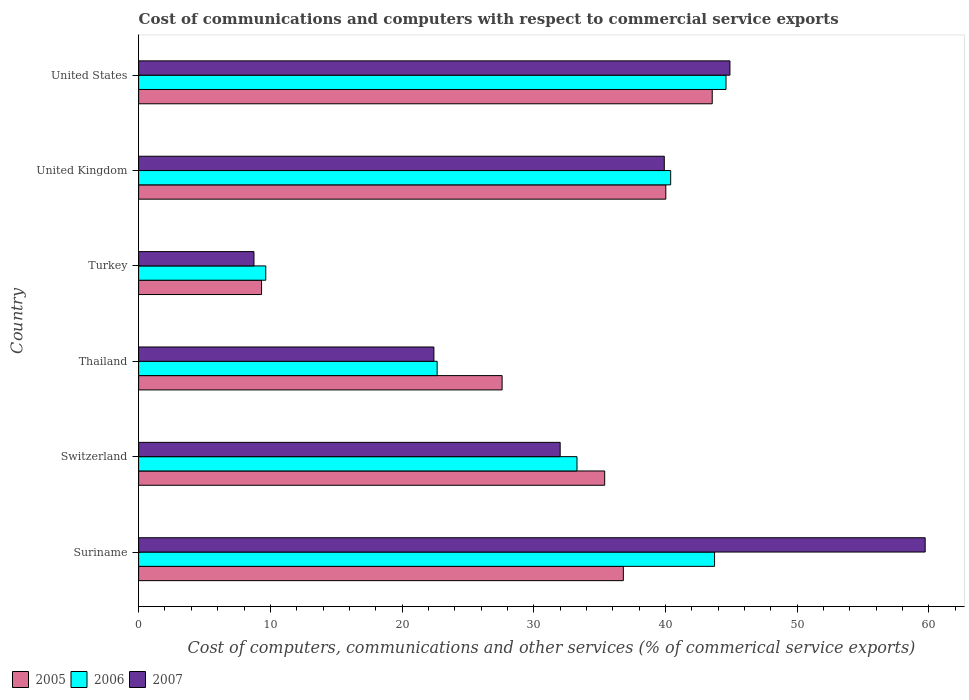How many different coloured bars are there?
Offer a terse response. 3. Are the number of bars on each tick of the Y-axis equal?
Provide a short and direct response. Yes. How many bars are there on the 2nd tick from the bottom?
Offer a very short reply. 3. What is the label of the 4th group of bars from the top?
Give a very brief answer. Thailand. In how many cases, is the number of bars for a given country not equal to the number of legend labels?
Provide a short and direct response. 0. What is the cost of communications and computers in 2005 in United States?
Your answer should be compact. 43.55. Across all countries, what is the maximum cost of communications and computers in 2006?
Provide a short and direct response. 44.6. Across all countries, what is the minimum cost of communications and computers in 2007?
Make the answer very short. 8.76. In which country was the cost of communications and computers in 2007 maximum?
Your response must be concise. Suriname. In which country was the cost of communications and computers in 2005 minimum?
Give a very brief answer. Turkey. What is the total cost of communications and computers in 2005 in the graph?
Ensure brevity in your answer.  192.69. What is the difference between the cost of communications and computers in 2007 in Suriname and that in United States?
Provide a succinct answer. 14.82. What is the difference between the cost of communications and computers in 2005 in Thailand and the cost of communications and computers in 2006 in United Kingdom?
Your answer should be compact. -12.8. What is the average cost of communications and computers in 2006 per country?
Give a very brief answer. 32.39. What is the difference between the cost of communications and computers in 2006 and cost of communications and computers in 2005 in United Kingdom?
Your response must be concise. 0.37. In how many countries, is the cost of communications and computers in 2005 greater than 20 %?
Offer a very short reply. 5. What is the ratio of the cost of communications and computers in 2005 in Suriname to that in United States?
Your answer should be compact. 0.85. What is the difference between the highest and the second highest cost of communications and computers in 2006?
Provide a short and direct response. 0.87. What is the difference between the highest and the lowest cost of communications and computers in 2007?
Provide a short and direct response. 50.96. In how many countries, is the cost of communications and computers in 2005 greater than the average cost of communications and computers in 2005 taken over all countries?
Make the answer very short. 4. Is the sum of the cost of communications and computers in 2007 in Thailand and United Kingdom greater than the maximum cost of communications and computers in 2006 across all countries?
Ensure brevity in your answer.  Yes. What does the 1st bar from the top in United Kingdom represents?
Keep it short and to the point. 2007. What does the 3rd bar from the bottom in United States represents?
Your answer should be compact. 2007. Is it the case that in every country, the sum of the cost of communications and computers in 2005 and cost of communications and computers in 2007 is greater than the cost of communications and computers in 2006?
Offer a very short reply. Yes. Are all the bars in the graph horizontal?
Ensure brevity in your answer.  Yes. How many countries are there in the graph?
Give a very brief answer. 6. Are the values on the major ticks of X-axis written in scientific E-notation?
Ensure brevity in your answer.  No. Where does the legend appear in the graph?
Offer a terse response. Bottom left. How many legend labels are there?
Offer a terse response. 3. What is the title of the graph?
Provide a short and direct response. Cost of communications and computers with respect to commercial service exports. Does "1997" appear as one of the legend labels in the graph?
Your response must be concise. No. What is the label or title of the X-axis?
Ensure brevity in your answer.  Cost of computers, communications and other services (% of commerical service exports). What is the label or title of the Y-axis?
Offer a terse response. Country. What is the Cost of computers, communications and other services (% of commerical service exports) in 2005 in Suriname?
Make the answer very short. 36.8. What is the Cost of computers, communications and other services (% of commerical service exports) of 2006 in Suriname?
Your answer should be compact. 43.73. What is the Cost of computers, communications and other services (% of commerical service exports) of 2007 in Suriname?
Provide a succinct answer. 59.72. What is the Cost of computers, communications and other services (% of commerical service exports) in 2005 in Switzerland?
Ensure brevity in your answer.  35.39. What is the Cost of computers, communications and other services (% of commerical service exports) in 2006 in Switzerland?
Your answer should be very brief. 33.28. What is the Cost of computers, communications and other services (% of commerical service exports) in 2007 in Switzerland?
Your answer should be very brief. 32. What is the Cost of computers, communications and other services (% of commerical service exports) in 2005 in Thailand?
Offer a very short reply. 27.6. What is the Cost of computers, communications and other services (% of commerical service exports) in 2006 in Thailand?
Provide a succinct answer. 22.66. What is the Cost of computers, communications and other services (% of commerical service exports) in 2007 in Thailand?
Your response must be concise. 22.42. What is the Cost of computers, communications and other services (% of commerical service exports) in 2005 in Turkey?
Your answer should be compact. 9.33. What is the Cost of computers, communications and other services (% of commerical service exports) in 2006 in Turkey?
Give a very brief answer. 9.65. What is the Cost of computers, communications and other services (% of commerical service exports) in 2007 in Turkey?
Offer a very short reply. 8.76. What is the Cost of computers, communications and other services (% of commerical service exports) in 2005 in United Kingdom?
Your answer should be compact. 40.03. What is the Cost of computers, communications and other services (% of commerical service exports) of 2006 in United Kingdom?
Keep it short and to the point. 40.39. What is the Cost of computers, communications and other services (% of commerical service exports) in 2007 in United Kingdom?
Provide a succinct answer. 39.91. What is the Cost of computers, communications and other services (% of commerical service exports) in 2005 in United States?
Your answer should be very brief. 43.55. What is the Cost of computers, communications and other services (% of commerical service exports) in 2006 in United States?
Your response must be concise. 44.6. What is the Cost of computers, communications and other services (% of commerical service exports) in 2007 in United States?
Ensure brevity in your answer.  44.89. Across all countries, what is the maximum Cost of computers, communications and other services (% of commerical service exports) in 2005?
Give a very brief answer. 43.55. Across all countries, what is the maximum Cost of computers, communications and other services (% of commerical service exports) in 2006?
Offer a terse response. 44.6. Across all countries, what is the maximum Cost of computers, communications and other services (% of commerical service exports) in 2007?
Provide a succinct answer. 59.72. Across all countries, what is the minimum Cost of computers, communications and other services (% of commerical service exports) of 2005?
Your answer should be compact. 9.33. Across all countries, what is the minimum Cost of computers, communications and other services (% of commerical service exports) in 2006?
Your answer should be very brief. 9.65. Across all countries, what is the minimum Cost of computers, communications and other services (% of commerical service exports) in 2007?
Give a very brief answer. 8.76. What is the total Cost of computers, communications and other services (% of commerical service exports) of 2005 in the graph?
Offer a very short reply. 192.69. What is the total Cost of computers, communications and other services (% of commerical service exports) of 2006 in the graph?
Give a very brief answer. 194.32. What is the total Cost of computers, communications and other services (% of commerical service exports) in 2007 in the graph?
Your response must be concise. 207.7. What is the difference between the Cost of computers, communications and other services (% of commerical service exports) in 2005 in Suriname and that in Switzerland?
Offer a very short reply. 1.42. What is the difference between the Cost of computers, communications and other services (% of commerical service exports) in 2006 in Suriname and that in Switzerland?
Provide a short and direct response. 10.44. What is the difference between the Cost of computers, communications and other services (% of commerical service exports) in 2007 in Suriname and that in Switzerland?
Ensure brevity in your answer.  27.71. What is the difference between the Cost of computers, communications and other services (% of commerical service exports) in 2005 in Suriname and that in Thailand?
Offer a terse response. 9.21. What is the difference between the Cost of computers, communications and other services (% of commerical service exports) of 2006 in Suriname and that in Thailand?
Ensure brevity in your answer.  21.06. What is the difference between the Cost of computers, communications and other services (% of commerical service exports) in 2007 in Suriname and that in Thailand?
Make the answer very short. 37.3. What is the difference between the Cost of computers, communications and other services (% of commerical service exports) in 2005 in Suriname and that in Turkey?
Your answer should be compact. 27.47. What is the difference between the Cost of computers, communications and other services (% of commerical service exports) of 2006 in Suriname and that in Turkey?
Offer a terse response. 34.07. What is the difference between the Cost of computers, communications and other services (% of commerical service exports) of 2007 in Suriname and that in Turkey?
Ensure brevity in your answer.  50.96. What is the difference between the Cost of computers, communications and other services (% of commerical service exports) in 2005 in Suriname and that in United Kingdom?
Offer a very short reply. -3.22. What is the difference between the Cost of computers, communications and other services (% of commerical service exports) in 2006 in Suriname and that in United Kingdom?
Ensure brevity in your answer.  3.33. What is the difference between the Cost of computers, communications and other services (% of commerical service exports) of 2007 in Suriname and that in United Kingdom?
Provide a short and direct response. 19.81. What is the difference between the Cost of computers, communications and other services (% of commerical service exports) of 2005 in Suriname and that in United States?
Give a very brief answer. -6.75. What is the difference between the Cost of computers, communications and other services (% of commerical service exports) in 2006 in Suriname and that in United States?
Your answer should be very brief. -0.87. What is the difference between the Cost of computers, communications and other services (% of commerical service exports) in 2007 in Suriname and that in United States?
Ensure brevity in your answer.  14.82. What is the difference between the Cost of computers, communications and other services (% of commerical service exports) in 2005 in Switzerland and that in Thailand?
Provide a succinct answer. 7.79. What is the difference between the Cost of computers, communications and other services (% of commerical service exports) of 2006 in Switzerland and that in Thailand?
Offer a very short reply. 10.62. What is the difference between the Cost of computers, communications and other services (% of commerical service exports) in 2007 in Switzerland and that in Thailand?
Your answer should be compact. 9.59. What is the difference between the Cost of computers, communications and other services (% of commerical service exports) in 2005 in Switzerland and that in Turkey?
Offer a terse response. 26.05. What is the difference between the Cost of computers, communications and other services (% of commerical service exports) of 2006 in Switzerland and that in Turkey?
Your response must be concise. 23.63. What is the difference between the Cost of computers, communications and other services (% of commerical service exports) of 2007 in Switzerland and that in Turkey?
Give a very brief answer. 23.25. What is the difference between the Cost of computers, communications and other services (% of commerical service exports) of 2005 in Switzerland and that in United Kingdom?
Offer a very short reply. -4.64. What is the difference between the Cost of computers, communications and other services (% of commerical service exports) in 2006 in Switzerland and that in United Kingdom?
Give a very brief answer. -7.11. What is the difference between the Cost of computers, communications and other services (% of commerical service exports) in 2007 in Switzerland and that in United Kingdom?
Offer a terse response. -7.91. What is the difference between the Cost of computers, communications and other services (% of commerical service exports) of 2005 in Switzerland and that in United States?
Make the answer very short. -8.17. What is the difference between the Cost of computers, communications and other services (% of commerical service exports) of 2006 in Switzerland and that in United States?
Provide a succinct answer. -11.31. What is the difference between the Cost of computers, communications and other services (% of commerical service exports) of 2007 in Switzerland and that in United States?
Ensure brevity in your answer.  -12.89. What is the difference between the Cost of computers, communications and other services (% of commerical service exports) of 2005 in Thailand and that in Turkey?
Your response must be concise. 18.26. What is the difference between the Cost of computers, communications and other services (% of commerical service exports) in 2006 in Thailand and that in Turkey?
Ensure brevity in your answer.  13.01. What is the difference between the Cost of computers, communications and other services (% of commerical service exports) of 2007 in Thailand and that in Turkey?
Make the answer very short. 13.66. What is the difference between the Cost of computers, communications and other services (% of commerical service exports) in 2005 in Thailand and that in United Kingdom?
Your answer should be very brief. -12.43. What is the difference between the Cost of computers, communications and other services (% of commerical service exports) in 2006 in Thailand and that in United Kingdom?
Offer a very short reply. -17.73. What is the difference between the Cost of computers, communications and other services (% of commerical service exports) in 2007 in Thailand and that in United Kingdom?
Your response must be concise. -17.49. What is the difference between the Cost of computers, communications and other services (% of commerical service exports) in 2005 in Thailand and that in United States?
Your response must be concise. -15.95. What is the difference between the Cost of computers, communications and other services (% of commerical service exports) of 2006 in Thailand and that in United States?
Provide a succinct answer. -21.93. What is the difference between the Cost of computers, communications and other services (% of commerical service exports) of 2007 in Thailand and that in United States?
Your response must be concise. -22.48. What is the difference between the Cost of computers, communications and other services (% of commerical service exports) in 2005 in Turkey and that in United Kingdom?
Provide a succinct answer. -30.69. What is the difference between the Cost of computers, communications and other services (% of commerical service exports) of 2006 in Turkey and that in United Kingdom?
Provide a succinct answer. -30.74. What is the difference between the Cost of computers, communications and other services (% of commerical service exports) in 2007 in Turkey and that in United Kingdom?
Offer a terse response. -31.15. What is the difference between the Cost of computers, communications and other services (% of commerical service exports) in 2005 in Turkey and that in United States?
Your response must be concise. -34.22. What is the difference between the Cost of computers, communications and other services (% of commerical service exports) in 2006 in Turkey and that in United States?
Offer a very short reply. -34.94. What is the difference between the Cost of computers, communications and other services (% of commerical service exports) in 2007 in Turkey and that in United States?
Give a very brief answer. -36.14. What is the difference between the Cost of computers, communications and other services (% of commerical service exports) in 2005 in United Kingdom and that in United States?
Your answer should be very brief. -3.53. What is the difference between the Cost of computers, communications and other services (% of commerical service exports) in 2006 in United Kingdom and that in United States?
Give a very brief answer. -4.2. What is the difference between the Cost of computers, communications and other services (% of commerical service exports) in 2007 in United Kingdom and that in United States?
Your answer should be very brief. -4.98. What is the difference between the Cost of computers, communications and other services (% of commerical service exports) of 2005 in Suriname and the Cost of computers, communications and other services (% of commerical service exports) of 2006 in Switzerland?
Your answer should be compact. 3.52. What is the difference between the Cost of computers, communications and other services (% of commerical service exports) of 2005 in Suriname and the Cost of computers, communications and other services (% of commerical service exports) of 2007 in Switzerland?
Provide a short and direct response. 4.8. What is the difference between the Cost of computers, communications and other services (% of commerical service exports) of 2006 in Suriname and the Cost of computers, communications and other services (% of commerical service exports) of 2007 in Switzerland?
Keep it short and to the point. 11.72. What is the difference between the Cost of computers, communications and other services (% of commerical service exports) of 2005 in Suriname and the Cost of computers, communications and other services (% of commerical service exports) of 2006 in Thailand?
Ensure brevity in your answer.  14.14. What is the difference between the Cost of computers, communications and other services (% of commerical service exports) of 2005 in Suriname and the Cost of computers, communications and other services (% of commerical service exports) of 2007 in Thailand?
Your answer should be compact. 14.38. What is the difference between the Cost of computers, communications and other services (% of commerical service exports) in 2006 in Suriname and the Cost of computers, communications and other services (% of commerical service exports) in 2007 in Thailand?
Keep it short and to the point. 21.31. What is the difference between the Cost of computers, communications and other services (% of commerical service exports) of 2005 in Suriname and the Cost of computers, communications and other services (% of commerical service exports) of 2006 in Turkey?
Offer a terse response. 27.15. What is the difference between the Cost of computers, communications and other services (% of commerical service exports) in 2005 in Suriname and the Cost of computers, communications and other services (% of commerical service exports) in 2007 in Turkey?
Provide a short and direct response. 28.05. What is the difference between the Cost of computers, communications and other services (% of commerical service exports) of 2006 in Suriname and the Cost of computers, communications and other services (% of commerical service exports) of 2007 in Turkey?
Your response must be concise. 34.97. What is the difference between the Cost of computers, communications and other services (% of commerical service exports) in 2005 in Suriname and the Cost of computers, communications and other services (% of commerical service exports) in 2006 in United Kingdom?
Your response must be concise. -3.59. What is the difference between the Cost of computers, communications and other services (% of commerical service exports) of 2005 in Suriname and the Cost of computers, communications and other services (% of commerical service exports) of 2007 in United Kingdom?
Make the answer very short. -3.11. What is the difference between the Cost of computers, communications and other services (% of commerical service exports) in 2006 in Suriname and the Cost of computers, communications and other services (% of commerical service exports) in 2007 in United Kingdom?
Ensure brevity in your answer.  3.82. What is the difference between the Cost of computers, communications and other services (% of commerical service exports) in 2005 in Suriname and the Cost of computers, communications and other services (% of commerical service exports) in 2006 in United States?
Give a very brief answer. -7.79. What is the difference between the Cost of computers, communications and other services (% of commerical service exports) in 2005 in Suriname and the Cost of computers, communications and other services (% of commerical service exports) in 2007 in United States?
Make the answer very short. -8.09. What is the difference between the Cost of computers, communications and other services (% of commerical service exports) in 2006 in Suriname and the Cost of computers, communications and other services (% of commerical service exports) in 2007 in United States?
Provide a succinct answer. -1.17. What is the difference between the Cost of computers, communications and other services (% of commerical service exports) of 2005 in Switzerland and the Cost of computers, communications and other services (% of commerical service exports) of 2006 in Thailand?
Offer a very short reply. 12.72. What is the difference between the Cost of computers, communications and other services (% of commerical service exports) in 2005 in Switzerland and the Cost of computers, communications and other services (% of commerical service exports) in 2007 in Thailand?
Ensure brevity in your answer.  12.97. What is the difference between the Cost of computers, communications and other services (% of commerical service exports) of 2006 in Switzerland and the Cost of computers, communications and other services (% of commerical service exports) of 2007 in Thailand?
Your answer should be very brief. 10.86. What is the difference between the Cost of computers, communications and other services (% of commerical service exports) in 2005 in Switzerland and the Cost of computers, communications and other services (% of commerical service exports) in 2006 in Turkey?
Keep it short and to the point. 25.73. What is the difference between the Cost of computers, communications and other services (% of commerical service exports) of 2005 in Switzerland and the Cost of computers, communications and other services (% of commerical service exports) of 2007 in Turkey?
Your response must be concise. 26.63. What is the difference between the Cost of computers, communications and other services (% of commerical service exports) of 2006 in Switzerland and the Cost of computers, communications and other services (% of commerical service exports) of 2007 in Turkey?
Ensure brevity in your answer.  24.53. What is the difference between the Cost of computers, communications and other services (% of commerical service exports) in 2005 in Switzerland and the Cost of computers, communications and other services (% of commerical service exports) in 2006 in United Kingdom?
Make the answer very short. -5.01. What is the difference between the Cost of computers, communications and other services (% of commerical service exports) in 2005 in Switzerland and the Cost of computers, communications and other services (% of commerical service exports) in 2007 in United Kingdom?
Your response must be concise. -4.52. What is the difference between the Cost of computers, communications and other services (% of commerical service exports) in 2006 in Switzerland and the Cost of computers, communications and other services (% of commerical service exports) in 2007 in United Kingdom?
Provide a short and direct response. -6.63. What is the difference between the Cost of computers, communications and other services (% of commerical service exports) in 2005 in Switzerland and the Cost of computers, communications and other services (% of commerical service exports) in 2006 in United States?
Your answer should be compact. -9.21. What is the difference between the Cost of computers, communications and other services (% of commerical service exports) of 2005 in Switzerland and the Cost of computers, communications and other services (% of commerical service exports) of 2007 in United States?
Make the answer very short. -9.51. What is the difference between the Cost of computers, communications and other services (% of commerical service exports) of 2006 in Switzerland and the Cost of computers, communications and other services (% of commerical service exports) of 2007 in United States?
Ensure brevity in your answer.  -11.61. What is the difference between the Cost of computers, communications and other services (% of commerical service exports) in 2005 in Thailand and the Cost of computers, communications and other services (% of commerical service exports) in 2006 in Turkey?
Provide a short and direct response. 17.94. What is the difference between the Cost of computers, communications and other services (% of commerical service exports) of 2005 in Thailand and the Cost of computers, communications and other services (% of commerical service exports) of 2007 in Turkey?
Give a very brief answer. 18.84. What is the difference between the Cost of computers, communications and other services (% of commerical service exports) of 2006 in Thailand and the Cost of computers, communications and other services (% of commerical service exports) of 2007 in Turkey?
Give a very brief answer. 13.91. What is the difference between the Cost of computers, communications and other services (% of commerical service exports) in 2005 in Thailand and the Cost of computers, communications and other services (% of commerical service exports) in 2006 in United Kingdom?
Provide a short and direct response. -12.8. What is the difference between the Cost of computers, communications and other services (% of commerical service exports) of 2005 in Thailand and the Cost of computers, communications and other services (% of commerical service exports) of 2007 in United Kingdom?
Give a very brief answer. -12.31. What is the difference between the Cost of computers, communications and other services (% of commerical service exports) of 2006 in Thailand and the Cost of computers, communications and other services (% of commerical service exports) of 2007 in United Kingdom?
Your response must be concise. -17.25. What is the difference between the Cost of computers, communications and other services (% of commerical service exports) in 2005 in Thailand and the Cost of computers, communications and other services (% of commerical service exports) in 2006 in United States?
Make the answer very short. -17. What is the difference between the Cost of computers, communications and other services (% of commerical service exports) in 2005 in Thailand and the Cost of computers, communications and other services (% of commerical service exports) in 2007 in United States?
Your answer should be very brief. -17.3. What is the difference between the Cost of computers, communications and other services (% of commerical service exports) of 2006 in Thailand and the Cost of computers, communications and other services (% of commerical service exports) of 2007 in United States?
Give a very brief answer. -22.23. What is the difference between the Cost of computers, communications and other services (% of commerical service exports) of 2005 in Turkey and the Cost of computers, communications and other services (% of commerical service exports) of 2006 in United Kingdom?
Give a very brief answer. -31.06. What is the difference between the Cost of computers, communications and other services (% of commerical service exports) in 2005 in Turkey and the Cost of computers, communications and other services (% of commerical service exports) in 2007 in United Kingdom?
Offer a very short reply. -30.58. What is the difference between the Cost of computers, communications and other services (% of commerical service exports) of 2006 in Turkey and the Cost of computers, communications and other services (% of commerical service exports) of 2007 in United Kingdom?
Keep it short and to the point. -30.26. What is the difference between the Cost of computers, communications and other services (% of commerical service exports) of 2005 in Turkey and the Cost of computers, communications and other services (% of commerical service exports) of 2006 in United States?
Offer a terse response. -35.26. What is the difference between the Cost of computers, communications and other services (% of commerical service exports) of 2005 in Turkey and the Cost of computers, communications and other services (% of commerical service exports) of 2007 in United States?
Ensure brevity in your answer.  -35.56. What is the difference between the Cost of computers, communications and other services (% of commerical service exports) in 2006 in Turkey and the Cost of computers, communications and other services (% of commerical service exports) in 2007 in United States?
Your answer should be compact. -35.24. What is the difference between the Cost of computers, communications and other services (% of commerical service exports) of 2005 in United Kingdom and the Cost of computers, communications and other services (% of commerical service exports) of 2006 in United States?
Give a very brief answer. -4.57. What is the difference between the Cost of computers, communications and other services (% of commerical service exports) of 2005 in United Kingdom and the Cost of computers, communications and other services (% of commerical service exports) of 2007 in United States?
Make the answer very short. -4.87. What is the difference between the Cost of computers, communications and other services (% of commerical service exports) of 2006 in United Kingdom and the Cost of computers, communications and other services (% of commerical service exports) of 2007 in United States?
Keep it short and to the point. -4.5. What is the average Cost of computers, communications and other services (% of commerical service exports) in 2005 per country?
Your response must be concise. 32.12. What is the average Cost of computers, communications and other services (% of commerical service exports) of 2006 per country?
Give a very brief answer. 32.39. What is the average Cost of computers, communications and other services (% of commerical service exports) in 2007 per country?
Offer a terse response. 34.62. What is the difference between the Cost of computers, communications and other services (% of commerical service exports) of 2005 and Cost of computers, communications and other services (% of commerical service exports) of 2006 in Suriname?
Provide a succinct answer. -6.92. What is the difference between the Cost of computers, communications and other services (% of commerical service exports) of 2005 and Cost of computers, communications and other services (% of commerical service exports) of 2007 in Suriname?
Provide a succinct answer. -22.91. What is the difference between the Cost of computers, communications and other services (% of commerical service exports) in 2006 and Cost of computers, communications and other services (% of commerical service exports) in 2007 in Suriname?
Offer a terse response. -15.99. What is the difference between the Cost of computers, communications and other services (% of commerical service exports) of 2005 and Cost of computers, communications and other services (% of commerical service exports) of 2006 in Switzerland?
Ensure brevity in your answer.  2.1. What is the difference between the Cost of computers, communications and other services (% of commerical service exports) of 2005 and Cost of computers, communications and other services (% of commerical service exports) of 2007 in Switzerland?
Ensure brevity in your answer.  3.38. What is the difference between the Cost of computers, communications and other services (% of commerical service exports) of 2006 and Cost of computers, communications and other services (% of commerical service exports) of 2007 in Switzerland?
Your response must be concise. 1.28. What is the difference between the Cost of computers, communications and other services (% of commerical service exports) of 2005 and Cost of computers, communications and other services (% of commerical service exports) of 2006 in Thailand?
Ensure brevity in your answer.  4.93. What is the difference between the Cost of computers, communications and other services (% of commerical service exports) of 2005 and Cost of computers, communications and other services (% of commerical service exports) of 2007 in Thailand?
Offer a very short reply. 5.18. What is the difference between the Cost of computers, communications and other services (% of commerical service exports) in 2006 and Cost of computers, communications and other services (% of commerical service exports) in 2007 in Thailand?
Offer a very short reply. 0.25. What is the difference between the Cost of computers, communications and other services (% of commerical service exports) of 2005 and Cost of computers, communications and other services (% of commerical service exports) of 2006 in Turkey?
Provide a short and direct response. -0.32. What is the difference between the Cost of computers, communications and other services (% of commerical service exports) in 2005 and Cost of computers, communications and other services (% of commerical service exports) in 2007 in Turkey?
Offer a very short reply. 0.58. What is the difference between the Cost of computers, communications and other services (% of commerical service exports) of 2006 and Cost of computers, communications and other services (% of commerical service exports) of 2007 in Turkey?
Give a very brief answer. 0.9. What is the difference between the Cost of computers, communications and other services (% of commerical service exports) of 2005 and Cost of computers, communications and other services (% of commerical service exports) of 2006 in United Kingdom?
Offer a terse response. -0.37. What is the difference between the Cost of computers, communications and other services (% of commerical service exports) of 2005 and Cost of computers, communications and other services (% of commerical service exports) of 2007 in United Kingdom?
Your answer should be very brief. 0.12. What is the difference between the Cost of computers, communications and other services (% of commerical service exports) in 2006 and Cost of computers, communications and other services (% of commerical service exports) in 2007 in United Kingdom?
Give a very brief answer. 0.48. What is the difference between the Cost of computers, communications and other services (% of commerical service exports) of 2005 and Cost of computers, communications and other services (% of commerical service exports) of 2006 in United States?
Offer a terse response. -1.05. What is the difference between the Cost of computers, communications and other services (% of commerical service exports) of 2005 and Cost of computers, communications and other services (% of commerical service exports) of 2007 in United States?
Offer a terse response. -1.34. What is the difference between the Cost of computers, communications and other services (% of commerical service exports) of 2006 and Cost of computers, communications and other services (% of commerical service exports) of 2007 in United States?
Make the answer very short. -0.3. What is the ratio of the Cost of computers, communications and other services (% of commerical service exports) of 2006 in Suriname to that in Switzerland?
Your answer should be very brief. 1.31. What is the ratio of the Cost of computers, communications and other services (% of commerical service exports) of 2007 in Suriname to that in Switzerland?
Ensure brevity in your answer.  1.87. What is the ratio of the Cost of computers, communications and other services (% of commerical service exports) of 2005 in Suriname to that in Thailand?
Your response must be concise. 1.33. What is the ratio of the Cost of computers, communications and other services (% of commerical service exports) of 2006 in Suriname to that in Thailand?
Your response must be concise. 1.93. What is the ratio of the Cost of computers, communications and other services (% of commerical service exports) of 2007 in Suriname to that in Thailand?
Provide a succinct answer. 2.66. What is the ratio of the Cost of computers, communications and other services (% of commerical service exports) in 2005 in Suriname to that in Turkey?
Provide a succinct answer. 3.94. What is the ratio of the Cost of computers, communications and other services (% of commerical service exports) in 2006 in Suriname to that in Turkey?
Offer a terse response. 4.53. What is the ratio of the Cost of computers, communications and other services (% of commerical service exports) in 2007 in Suriname to that in Turkey?
Keep it short and to the point. 6.82. What is the ratio of the Cost of computers, communications and other services (% of commerical service exports) in 2005 in Suriname to that in United Kingdom?
Offer a terse response. 0.92. What is the ratio of the Cost of computers, communications and other services (% of commerical service exports) in 2006 in Suriname to that in United Kingdom?
Make the answer very short. 1.08. What is the ratio of the Cost of computers, communications and other services (% of commerical service exports) in 2007 in Suriname to that in United Kingdom?
Your response must be concise. 1.5. What is the ratio of the Cost of computers, communications and other services (% of commerical service exports) in 2005 in Suriname to that in United States?
Offer a terse response. 0.84. What is the ratio of the Cost of computers, communications and other services (% of commerical service exports) of 2006 in Suriname to that in United States?
Your answer should be compact. 0.98. What is the ratio of the Cost of computers, communications and other services (% of commerical service exports) of 2007 in Suriname to that in United States?
Offer a very short reply. 1.33. What is the ratio of the Cost of computers, communications and other services (% of commerical service exports) of 2005 in Switzerland to that in Thailand?
Keep it short and to the point. 1.28. What is the ratio of the Cost of computers, communications and other services (% of commerical service exports) of 2006 in Switzerland to that in Thailand?
Your answer should be compact. 1.47. What is the ratio of the Cost of computers, communications and other services (% of commerical service exports) of 2007 in Switzerland to that in Thailand?
Ensure brevity in your answer.  1.43. What is the ratio of the Cost of computers, communications and other services (% of commerical service exports) of 2005 in Switzerland to that in Turkey?
Your response must be concise. 3.79. What is the ratio of the Cost of computers, communications and other services (% of commerical service exports) in 2006 in Switzerland to that in Turkey?
Ensure brevity in your answer.  3.45. What is the ratio of the Cost of computers, communications and other services (% of commerical service exports) of 2007 in Switzerland to that in Turkey?
Your answer should be compact. 3.65. What is the ratio of the Cost of computers, communications and other services (% of commerical service exports) in 2005 in Switzerland to that in United Kingdom?
Your answer should be very brief. 0.88. What is the ratio of the Cost of computers, communications and other services (% of commerical service exports) in 2006 in Switzerland to that in United Kingdom?
Your answer should be compact. 0.82. What is the ratio of the Cost of computers, communications and other services (% of commerical service exports) of 2007 in Switzerland to that in United Kingdom?
Give a very brief answer. 0.8. What is the ratio of the Cost of computers, communications and other services (% of commerical service exports) of 2005 in Switzerland to that in United States?
Your answer should be very brief. 0.81. What is the ratio of the Cost of computers, communications and other services (% of commerical service exports) of 2006 in Switzerland to that in United States?
Offer a terse response. 0.75. What is the ratio of the Cost of computers, communications and other services (% of commerical service exports) of 2007 in Switzerland to that in United States?
Offer a very short reply. 0.71. What is the ratio of the Cost of computers, communications and other services (% of commerical service exports) in 2005 in Thailand to that in Turkey?
Provide a succinct answer. 2.96. What is the ratio of the Cost of computers, communications and other services (% of commerical service exports) of 2006 in Thailand to that in Turkey?
Your answer should be very brief. 2.35. What is the ratio of the Cost of computers, communications and other services (% of commerical service exports) of 2007 in Thailand to that in Turkey?
Your answer should be very brief. 2.56. What is the ratio of the Cost of computers, communications and other services (% of commerical service exports) of 2005 in Thailand to that in United Kingdom?
Your answer should be compact. 0.69. What is the ratio of the Cost of computers, communications and other services (% of commerical service exports) in 2006 in Thailand to that in United Kingdom?
Make the answer very short. 0.56. What is the ratio of the Cost of computers, communications and other services (% of commerical service exports) of 2007 in Thailand to that in United Kingdom?
Make the answer very short. 0.56. What is the ratio of the Cost of computers, communications and other services (% of commerical service exports) in 2005 in Thailand to that in United States?
Make the answer very short. 0.63. What is the ratio of the Cost of computers, communications and other services (% of commerical service exports) in 2006 in Thailand to that in United States?
Offer a very short reply. 0.51. What is the ratio of the Cost of computers, communications and other services (% of commerical service exports) in 2007 in Thailand to that in United States?
Provide a short and direct response. 0.5. What is the ratio of the Cost of computers, communications and other services (% of commerical service exports) in 2005 in Turkey to that in United Kingdom?
Your response must be concise. 0.23. What is the ratio of the Cost of computers, communications and other services (% of commerical service exports) of 2006 in Turkey to that in United Kingdom?
Provide a succinct answer. 0.24. What is the ratio of the Cost of computers, communications and other services (% of commerical service exports) in 2007 in Turkey to that in United Kingdom?
Provide a short and direct response. 0.22. What is the ratio of the Cost of computers, communications and other services (% of commerical service exports) in 2005 in Turkey to that in United States?
Give a very brief answer. 0.21. What is the ratio of the Cost of computers, communications and other services (% of commerical service exports) in 2006 in Turkey to that in United States?
Your answer should be compact. 0.22. What is the ratio of the Cost of computers, communications and other services (% of commerical service exports) in 2007 in Turkey to that in United States?
Keep it short and to the point. 0.2. What is the ratio of the Cost of computers, communications and other services (% of commerical service exports) in 2005 in United Kingdom to that in United States?
Your response must be concise. 0.92. What is the ratio of the Cost of computers, communications and other services (% of commerical service exports) in 2006 in United Kingdom to that in United States?
Offer a terse response. 0.91. What is the ratio of the Cost of computers, communications and other services (% of commerical service exports) of 2007 in United Kingdom to that in United States?
Offer a very short reply. 0.89. What is the difference between the highest and the second highest Cost of computers, communications and other services (% of commerical service exports) of 2005?
Ensure brevity in your answer.  3.53. What is the difference between the highest and the second highest Cost of computers, communications and other services (% of commerical service exports) in 2006?
Make the answer very short. 0.87. What is the difference between the highest and the second highest Cost of computers, communications and other services (% of commerical service exports) of 2007?
Offer a very short reply. 14.82. What is the difference between the highest and the lowest Cost of computers, communications and other services (% of commerical service exports) of 2005?
Ensure brevity in your answer.  34.22. What is the difference between the highest and the lowest Cost of computers, communications and other services (% of commerical service exports) of 2006?
Provide a short and direct response. 34.94. What is the difference between the highest and the lowest Cost of computers, communications and other services (% of commerical service exports) in 2007?
Ensure brevity in your answer.  50.96. 